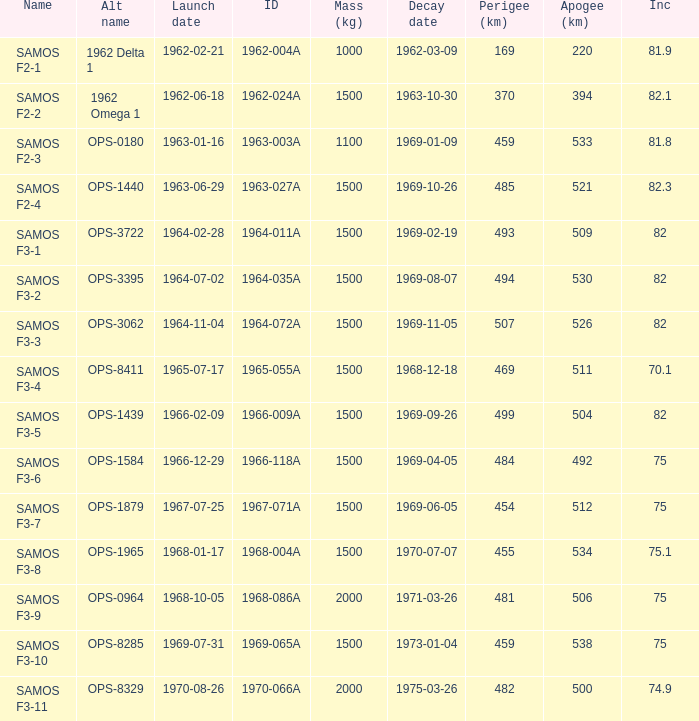Help me parse the entirety of this table. {'header': ['Name', 'Alt name', 'Launch date', 'ID', 'Mass (kg)', 'Decay date', 'Perigee (km)', 'Apogee (km)', 'Inc'], 'rows': [['SAMOS F2-1', '1962 Delta 1', '1962-02-21', '1962-004A', '1000', '1962-03-09', '169', '220', '81.9'], ['SAMOS F2-2', '1962 Omega 1', '1962-06-18', '1962-024A', '1500', '1963-10-30', '370', '394', '82.1'], ['SAMOS F2-3', 'OPS-0180', '1963-01-16', '1963-003A', '1100', '1969-01-09', '459', '533', '81.8'], ['SAMOS F2-4', 'OPS-1440', '1963-06-29', '1963-027A', '1500', '1969-10-26', '485', '521', '82.3'], ['SAMOS F3-1', 'OPS-3722', '1964-02-28', '1964-011A', '1500', '1969-02-19', '493', '509', '82'], ['SAMOS F3-2', 'OPS-3395', '1964-07-02', '1964-035A', '1500', '1969-08-07', '494', '530', '82'], ['SAMOS F3-3', 'OPS-3062', '1964-11-04', '1964-072A', '1500', '1969-11-05', '507', '526', '82'], ['SAMOS F3-4', 'OPS-8411', '1965-07-17', '1965-055A', '1500', '1968-12-18', '469', '511', '70.1'], ['SAMOS F3-5', 'OPS-1439', '1966-02-09', '1966-009A', '1500', '1969-09-26', '499', '504', '82'], ['SAMOS F3-6', 'OPS-1584', '1966-12-29', '1966-118A', '1500', '1969-04-05', '484', '492', '75'], ['SAMOS F3-7', 'OPS-1879', '1967-07-25', '1967-071A', '1500', '1969-06-05', '454', '512', '75'], ['SAMOS F3-8', 'OPS-1965', '1968-01-17', '1968-004A', '1500', '1970-07-07', '455', '534', '75.1'], ['SAMOS F3-9', 'OPS-0964', '1968-10-05', '1968-086A', '2000', '1971-03-26', '481', '506', '75'], ['SAMOS F3-10', 'OPS-8285', '1969-07-31', '1969-065A', '1500', '1973-01-04', '459', '538', '75'], ['SAMOS F3-11', 'OPS-8329', '1970-08-26', '1970-066A', '2000', '1975-03-26', '482', '500', '74.9']]} What is the maximum apogee for samos f3-3? 526.0. 